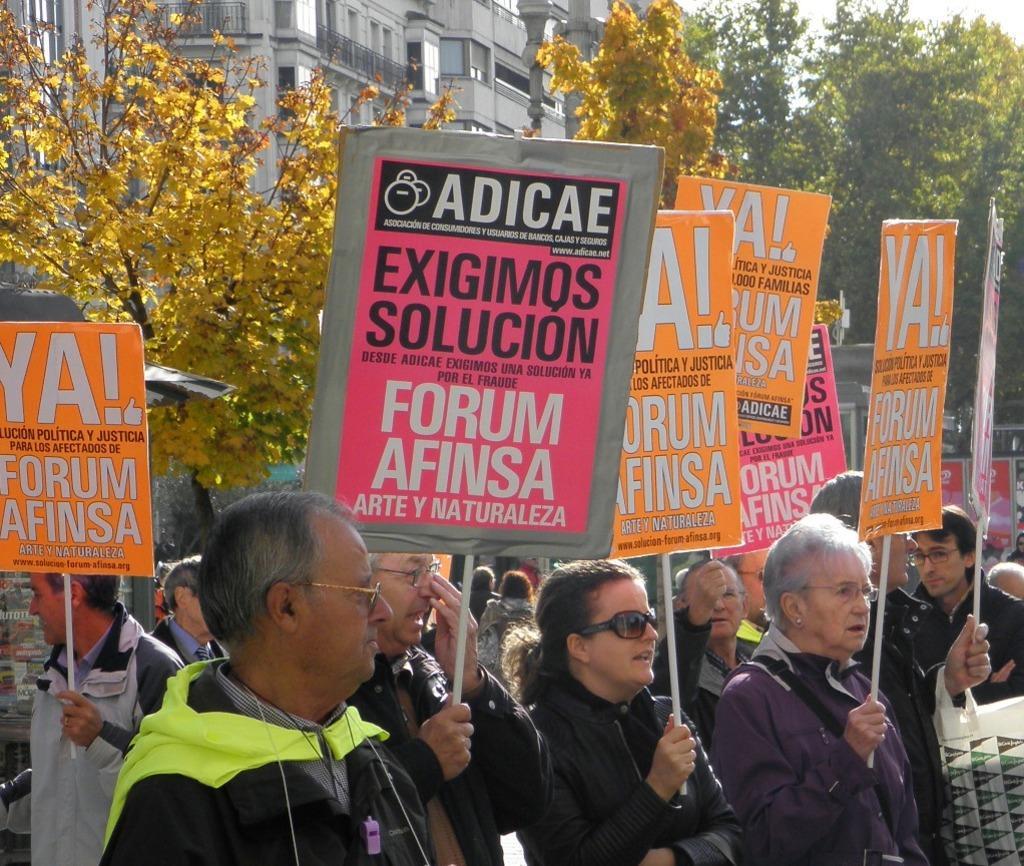How would you summarize this image in a sentence or two? In this image there are a few people standing and holding placards in their hands, behind them there are trees and buildings. 